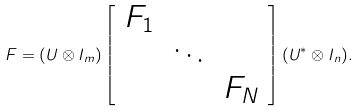<formula> <loc_0><loc_0><loc_500><loc_500>F = ( U \otimes I _ { m } ) \left [ \begin{array} { c c c } F _ { 1 } & & \\ & \ddots & \\ & & F _ { N } \end{array} \right ] ( U ^ { * } \otimes I _ { n } ) .</formula> 